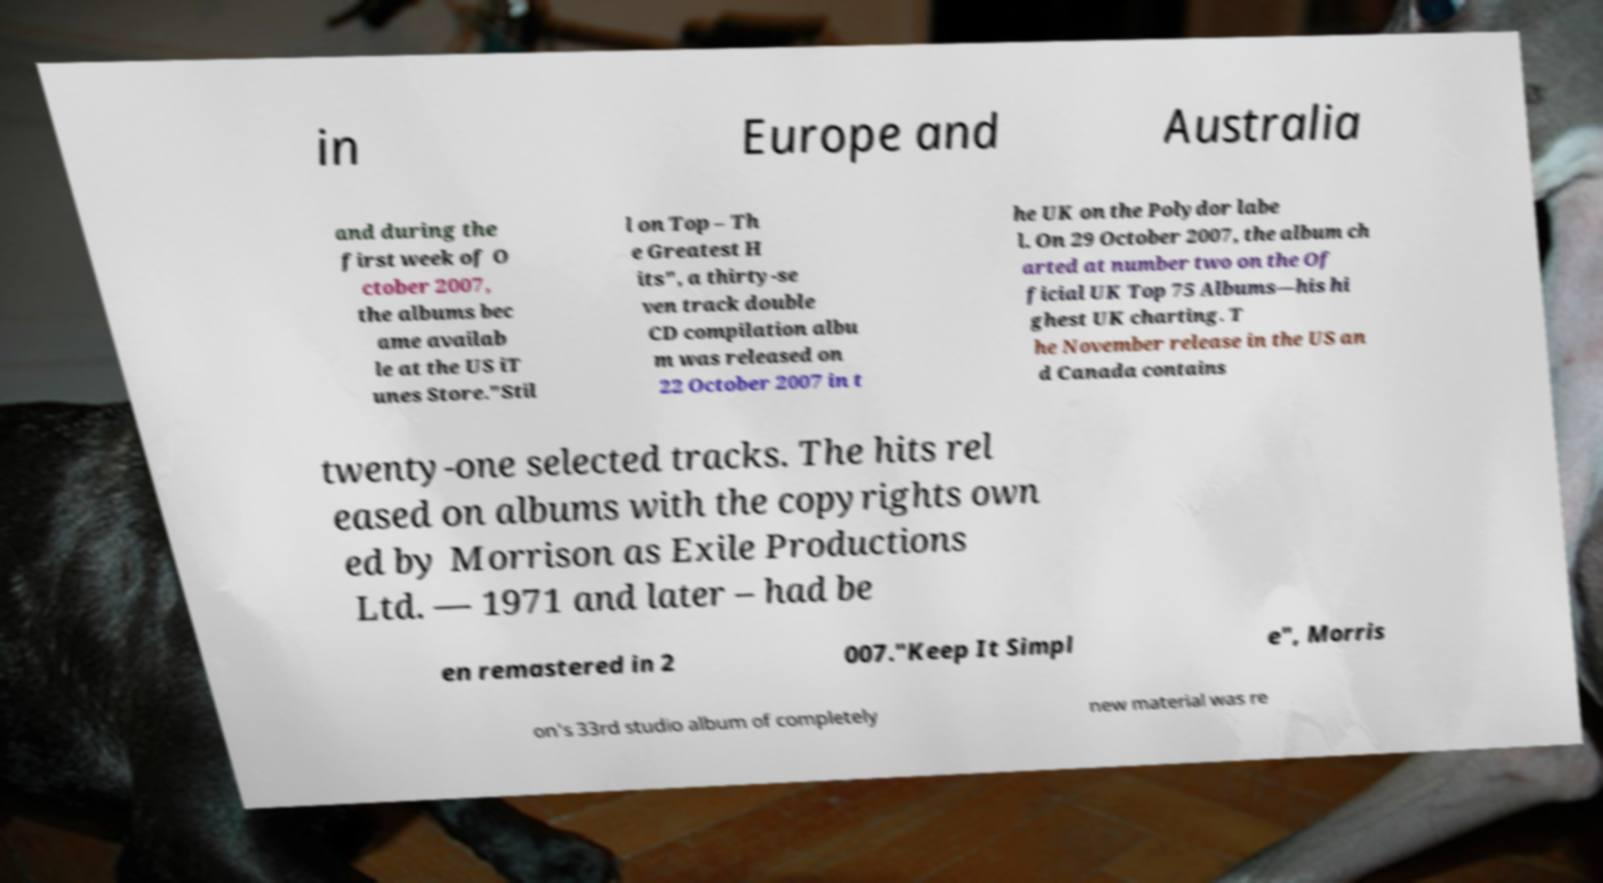What messages or text are displayed in this image? I need them in a readable, typed format. in Europe and Australia and during the first week of O ctober 2007, the albums bec ame availab le at the US iT unes Store."Stil l on Top – Th e Greatest H its", a thirty-se ven track double CD compilation albu m was released on 22 October 2007 in t he UK on the Polydor labe l. On 29 October 2007, the album ch arted at number two on the Of ficial UK Top 75 Albums—his hi ghest UK charting. T he November release in the US an d Canada contains twenty-one selected tracks. The hits rel eased on albums with the copyrights own ed by Morrison as Exile Productions Ltd. — 1971 and later – had be en remastered in 2 007."Keep It Simpl e", Morris on's 33rd studio album of completely new material was re 